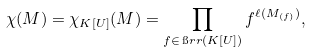Convert formula to latex. <formula><loc_0><loc_0><loc_500><loc_500>\chi ( M ) = \chi _ { K [ U ] } ( M ) = \prod _ { f \in \, \i r r ( K [ U ] ) } f ^ { \ell ( M _ { ( f ) } ) } ,</formula> 